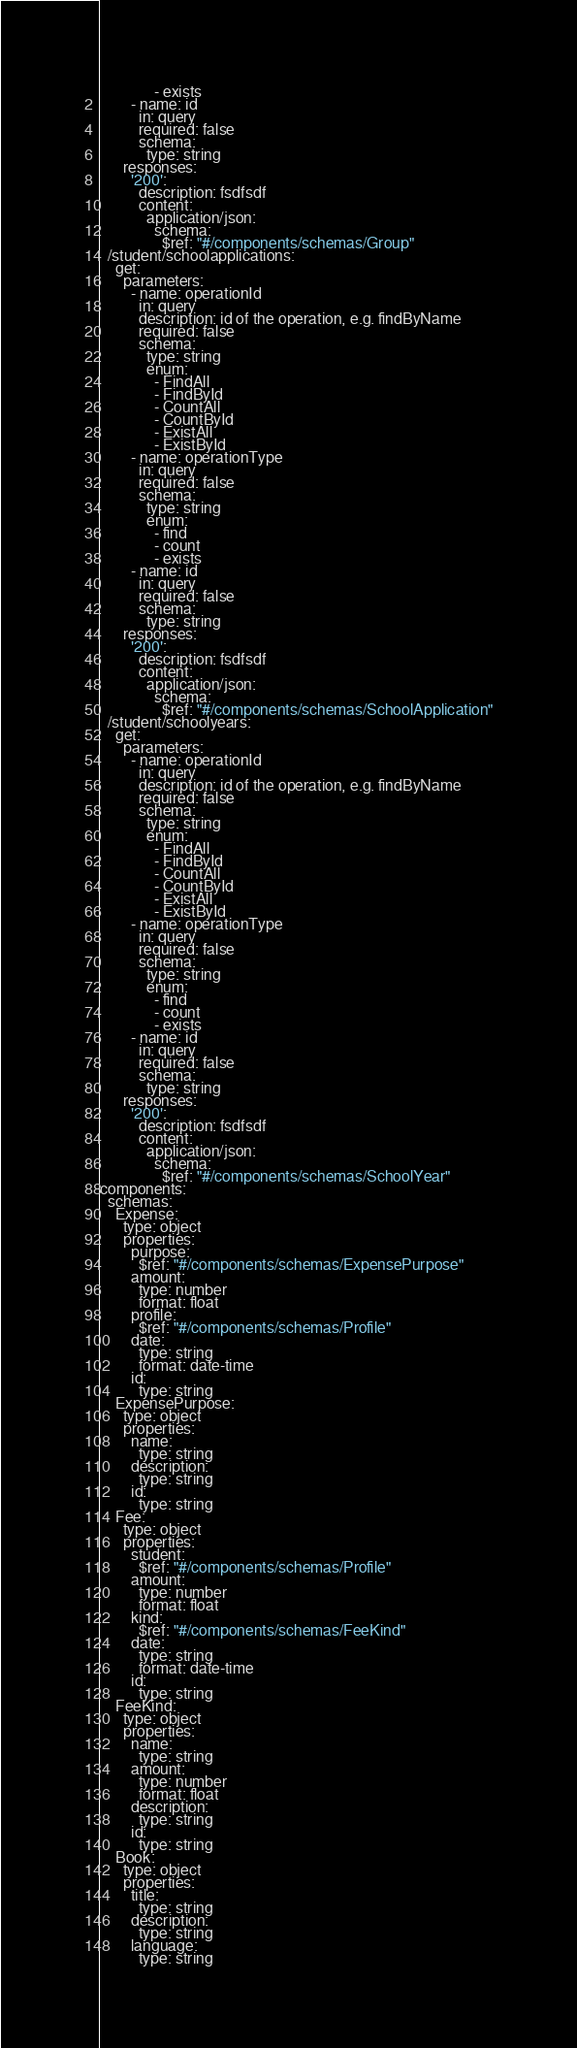Convert code to text. <code><loc_0><loc_0><loc_500><loc_500><_YAML_>              - exists
        - name: id
          in: query
          required: false
          schema:            
            type: string
      responses:
        '200':
          description: fsdfsdf
          content:
            application/json:
              schema:
                $ref: "#/components/schemas/Group"
  /student/schoolapplications:
    get:
      parameters:
        - name: operationId
          in: query
          description: id of the operation, e.g. findByName
          required: false
          schema:
            type: string
            enum: 
              - FindAll
              - FindById
              - CountAll
              - CountById
              - ExistAll
              - ExistById
        - name: operationType
          in: query
          required: false
          schema:
            type: string
            enum: 
              - find
              - count
              - exists
        - name: id
          in: query
          required: false
          schema:            
            type: string
      responses:
        '200':
          description: fsdfsdf
          content:
            application/json:
              schema:
                $ref: "#/components/schemas/SchoolApplication"
  /student/schoolyears:
    get:
      parameters:
        - name: operationId
          in: query
          description: id of the operation, e.g. findByName
          required: false
          schema:
            type: string
            enum: 
              - FindAll
              - FindById
              - CountAll
              - CountById
              - ExistAll
              - ExistById
        - name: operationType
          in: query
          required: false
          schema:
            type: string
            enum: 
              - find
              - count
              - exists
        - name: id
          in: query
          required: false
          schema:            
            type: string
      responses:
        '200':
          description: fsdfsdf
          content:
            application/json:
              schema:
                $ref: "#/components/schemas/SchoolYear"
components:
  schemas:
    Expense:
      type: object
      properties:
        purpose:          
          $ref: "#/components/schemas/ExpensePurpose"
        amount:          
          type: number
          format: float
        profile:          
          $ref: "#/components/schemas/Profile"
        date:          
          type: string
          format: date-time
        id:          
          type: string
    ExpensePurpose:
      type: object
      properties:
        name:          
          type: string
        description:          
          type: string
        id:          
          type: string
    Fee:
      type: object
      properties:
        student:          
          $ref: "#/components/schemas/Profile"
        amount:          
          type: number
          format: float
        kind:          
          $ref: "#/components/schemas/FeeKind"
        date:          
          type: string
          format: date-time
        id:          
          type: string
    FeeKind:
      type: object
      properties:
        name:          
          type: string
        amount:          
          type: number
          format: float
        description:          
          type: string
        id:          
          type: string
    Book:
      type: object
      properties:
        title:          
          type: string
        description:          
          type: string
        language:          
          type: string</code> 